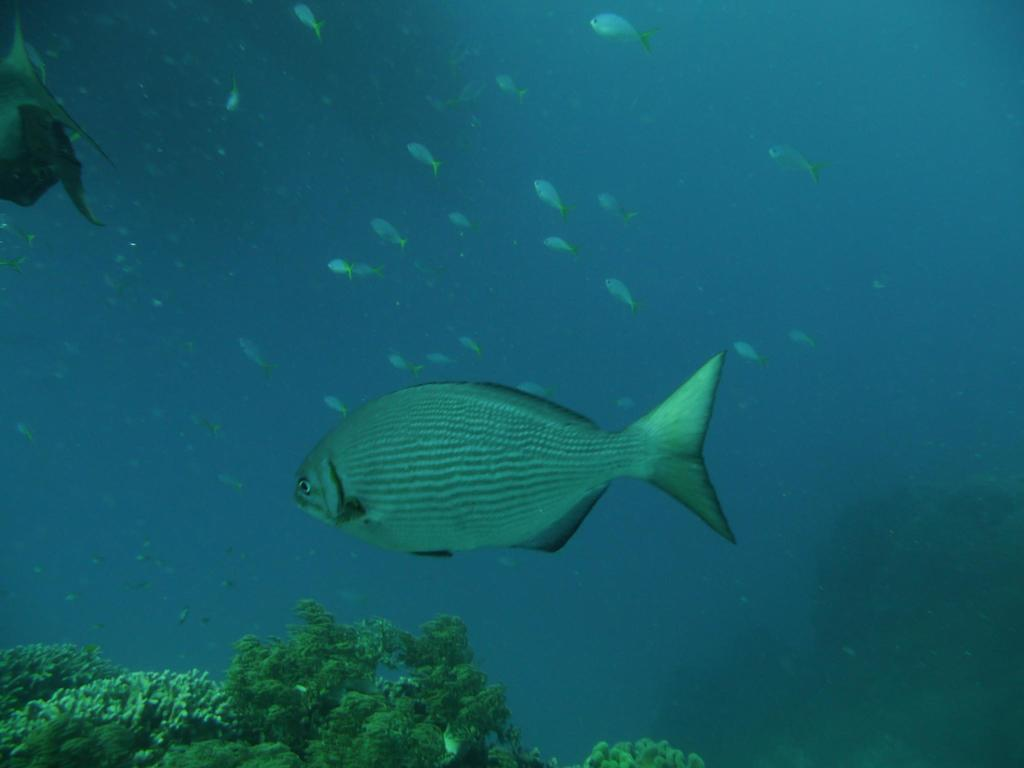What type of animals can be seen in the image? There are fishes in the image. Where are the fishes located? The fishes are in the water. What other aquatic element is present in the image? There is a marine plant in the image. How many people are in the crowd surrounding the fishes in the image? There is no crowd present in the image; it features fishes in the water with a marine plant. What type of education do the fishes in the image have? The image does not provide information about the education of the fishes, as they are aquatic animals and do not attend educational institutions. 